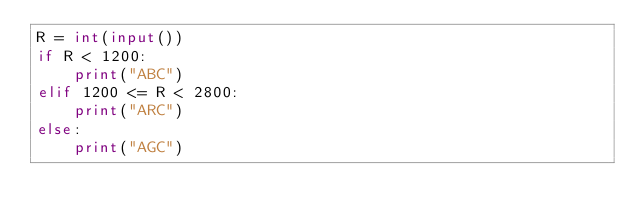Convert code to text. <code><loc_0><loc_0><loc_500><loc_500><_Python_>R = int(input())
if R < 1200:
    print("ABC")
elif 1200 <= R < 2800:
    print("ARC")
else:
    print("AGC")</code> 